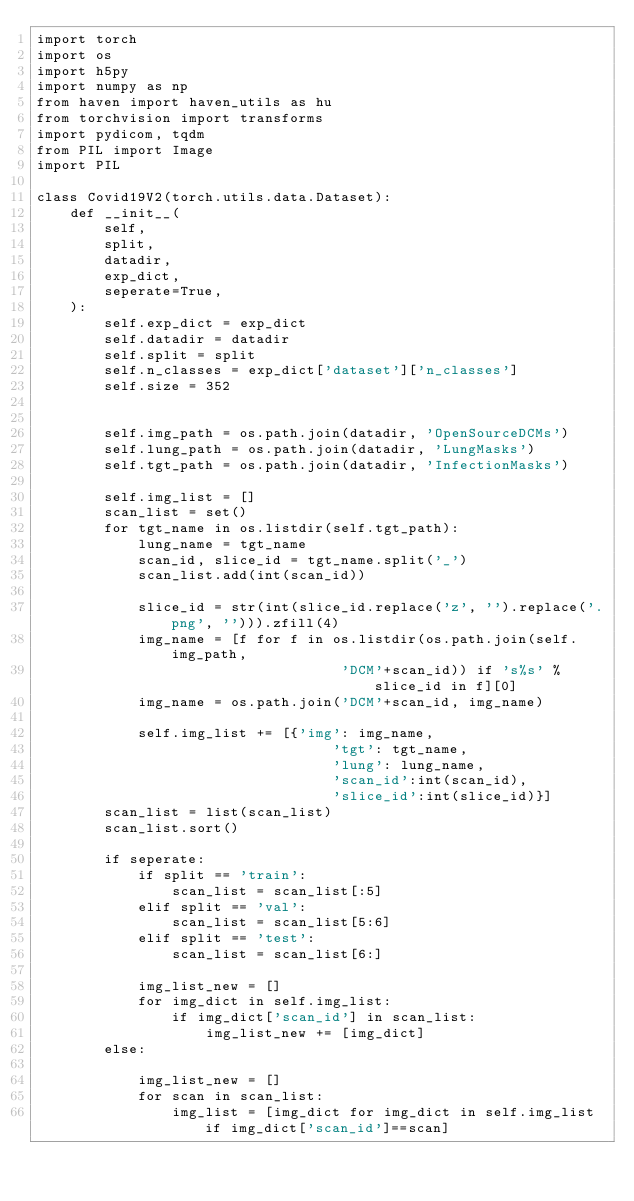Convert code to text. <code><loc_0><loc_0><loc_500><loc_500><_Python_>import torch
import os
import h5py
import numpy as np
from haven import haven_utils as hu
from torchvision import transforms
import pydicom, tqdm
from PIL import Image
import PIL

class Covid19V2(torch.utils.data.Dataset):
    def __init__(
        self,
        split,
        datadir,
        exp_dict,
        seperate=True,
    ):
        self.exp_dict = exp_dict
        self.datadir = datadir
        self.split = split
        self.n_classes = exp_dict['dataset']['n_classes']
        self.size = 352


        self.img_path = os.path.join(datadir, 'OpenSourceDCMs')
        self.lung_path = os.path.join(datadir, 'LungMasks')
        self.tgt_path = os.path.join(datadir, 'InfectionMasks')

        self.img_list = []
        scan_list = set()
        for tgt_name in os.listdir(self.tgt_path):
            lung_name = tgt_name
            scan_id, slice_id = tgt_name.split('_')
            scan_list.add(int(scan_id))

            slice_id = str(int(slice_id.replace('z', '').replace('.png', ''))).zfill(4)
            img_name = [f for f in os.listdir(os.path.join(self.img_path, 
                                    'DCM'+scan_id)) if 's%s' % slice_id in f][0]
            img_name = os.path.join('DCM'+scan_id, img_name)

            self.img_list += [{'img': img_name, 
                                   'tgt': tgt_name,
                                   'lung': lung_name,
                                   'scan_id':int(scan_id),
                                   'slice_id':int(slice_id)}]
        scan_list = list(scan_list)
        scan_list.sort()

        if seperate:
            if split == 'train':
                scan_list = scan_list[:5]
            elif split == 'val':
                scan_list = scan_list[5:6]
            elif split == 'test':
                scan_list = scan_list[6:]

            img_list_new = []
            for img_dict in self.img_list:
                if img_dict['scan_id'] in scan_list:
                    img_list_new += [img_dict]
        else:

            img_list_new = []
            for scan in scan_list:
                img_list = [img_dict for img_dict in self.img_list if img_dict['scan_id']==scan]</code> 